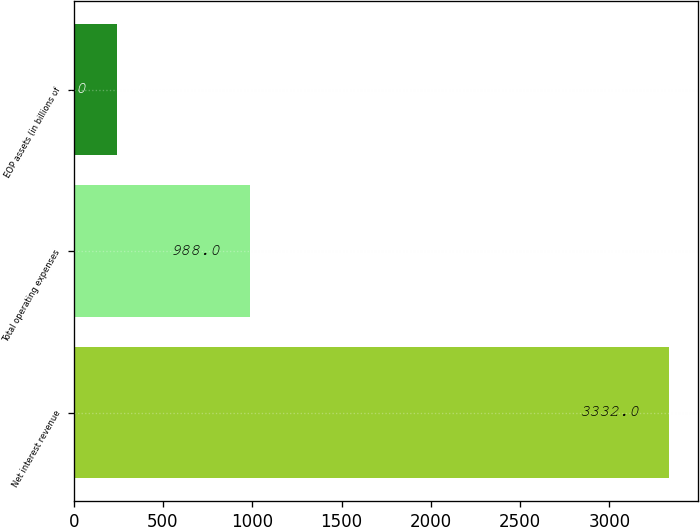Convert chart to OTSL. <chart><loc_0><loc_0><loc_500><loc_500><bar_chart><fcel>Net interest revenue<fcel>Total operating expenses<fcel>EOP assets (in billions of<nl><fcel>3332<fcel>988<fcel>241<nl></chart> 